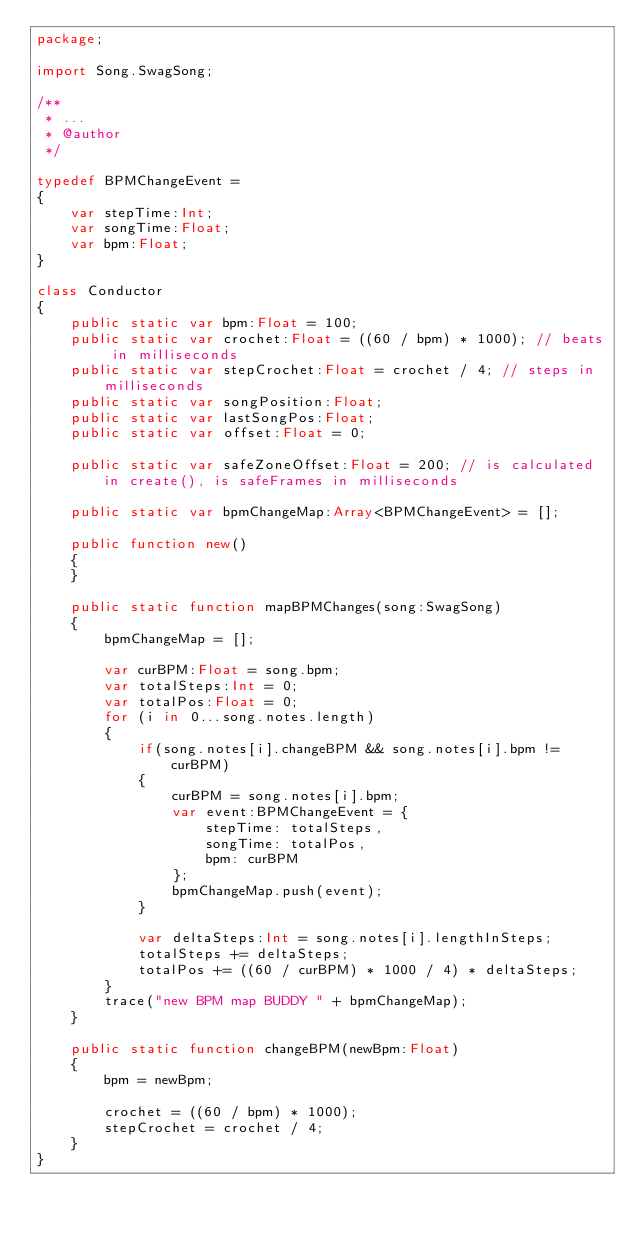<code> <loc_0><loc_0><loc_500><loc_500><_Haxe_>package;

import Song.SwagSong;

/**
 * ...
 * @author
 */

typedef BPMChangeEvent =
{
	var stepTime:Int;
	var songTime:Float;
	var bpm:Float;
}

class Conductor
{
	public static var bpm:Float = 100;
	public static var crochet:Float = ((60 / bpm) * 1000); // beats in milliseconds
	public static var stepCrochet:Float = crochet / 4; // steps in milliseconds
	public static var songPosition:Float;
	public static var lastSongPos:Float;
	public static var offset:Float = 0;

	public static var safeZoneOffset:Float = 200; // is calculated in create(), is safeFrames in milliseconds

	public static var bpmChangeMap:Array<BPMChangeEvent> = [];

	public function new()
	{
	}

	public static function mapBPMChanges(song:SwagSong)
	{
		bpmChangeMap = [];

		var curBPM:Float = song.bpm;
		var totalSteps:Int = 0;
		var totalPos:Float = 0;
		for (i in 0...song.notes.length)
		{
			if(song.notes[i].changeBPM && song.notes[i].bpm != curBPM)
			{
				curBPM = song.notes[i].bpm;
				var event:BPMChangeEvent = {
					stepTime: totalSteps,
					songTime: totalPos,
					bpm: curBPM
				};
				bpmChangeMap.push(event);
			}

			var deltaSteps:Int = song.notes[i].lengthInSteps;
			totalSteps += deltaSteps;
			totalPos += ((60 / curBPM) * 1000 / 4) * deltaSteps;
		}
		trace("new BPM map BUDDY " + bpmChangeMap);
	}

	public static function changeBPM(newBpm:Float)
	{
		bpm = newBpm;

		crochet = ((60 / bpm) * 1000);
		stepCrochet = crochet / 4;
	}
}
</code> 